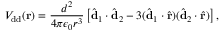Convert formula to latex. <formula><loc_0><loc_0><loc_500><loc_500>V _ { d d } ( { r } ) = \frac { d ^ { 2 } } { 4 \pi \epsilon _ { 0 } r ^ { 3 } } \left [ \hat { d } _ { 1 } \cdot \hat { d } _ { 2 } - 3 ( \hat { d } _ { 1 } \cdot \hat { r } ) ( \hat { d } _ { 2 } \cdot \hat { r } ) \right ] ,</formula> 